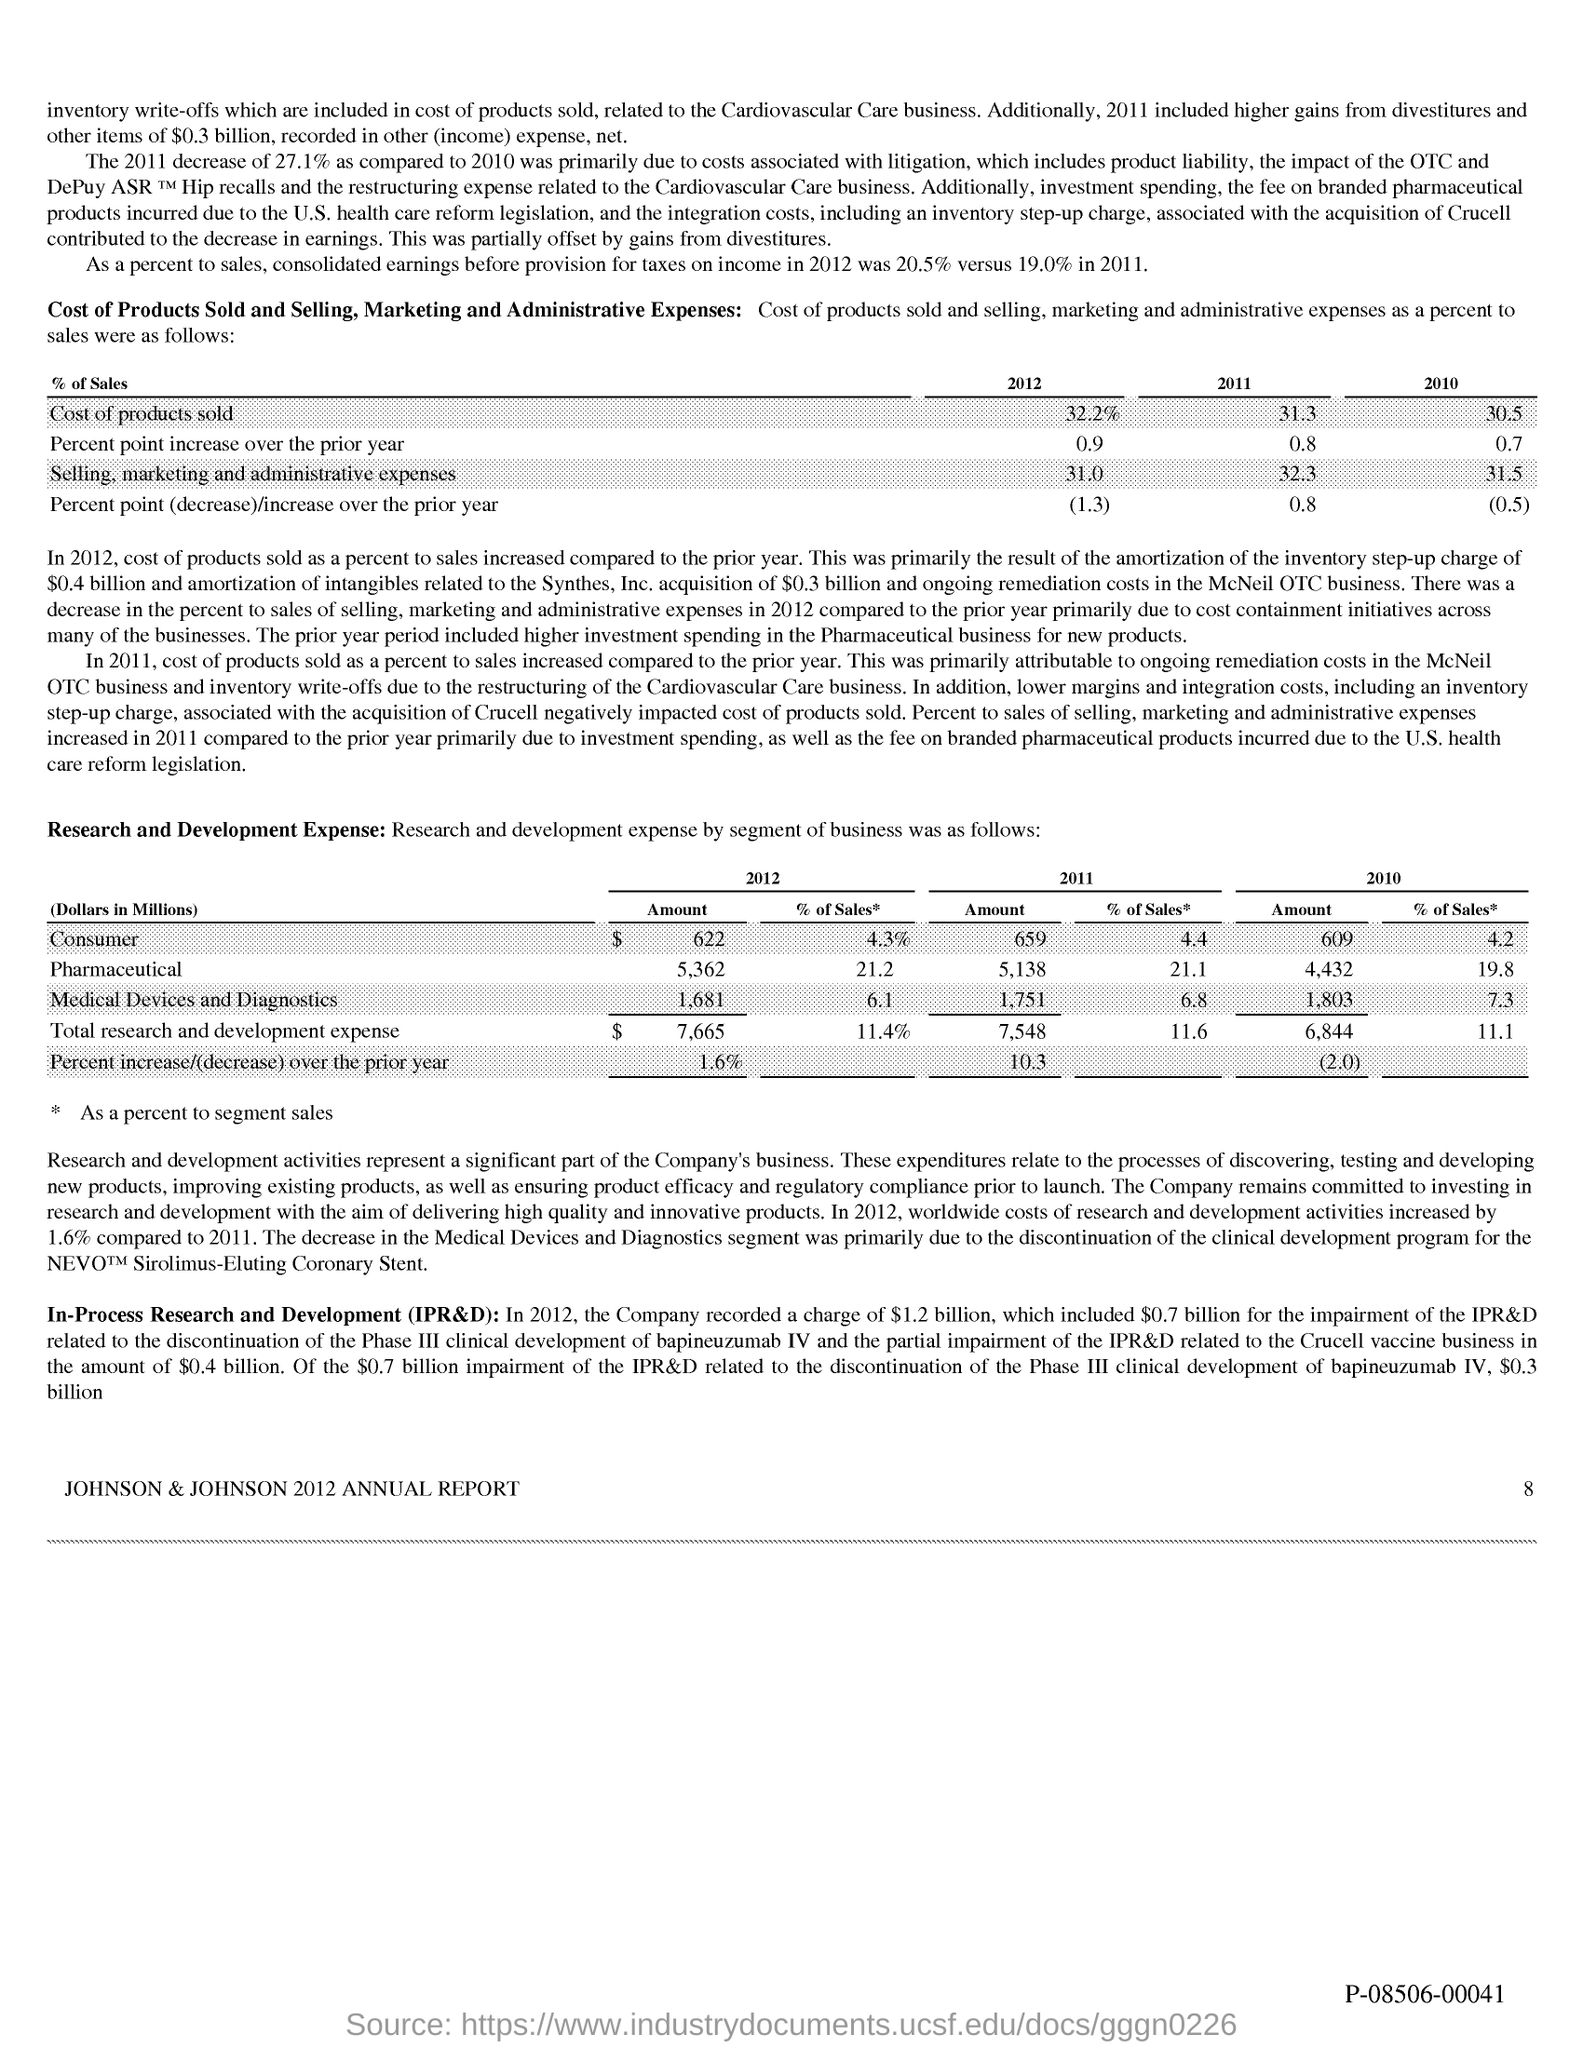What is the title of this report?
Your answer should be very brief. JOHNSON & JOHNSON 2012 ANNUAL REPORT. 